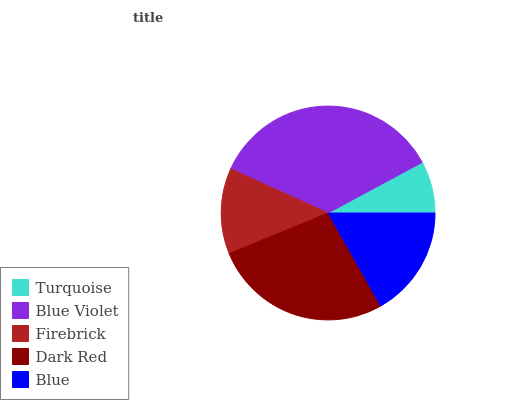Is Turquoise the minimum?
Answer yes or no. Yes. Is Blue Violet the maximum?
Answer yes or no. Yes. Is Firebrick the minimum?
Answer yes or no. No. Is Firebrick the maximum?
Answer yes or no. No. Is Blue Violet greater than Firebrick?
Answer yes or no. Yes. Is Firebrick less than Blue Violet?
Answer yes or no. Yes. Is Firebrick greater than Blue Violet?
Answer yes or no. No. Is Blue Violet less than Firebrick?
Answer yes or no. No. Is Blue the high median?
Answer yes or no. Yes. Is Blue the low median?
Answer yes or no. Yes. Is Blue Violet the high median?
Answer yes or no. No. Is Dark Red the low median?
Answer yes or no. No. 